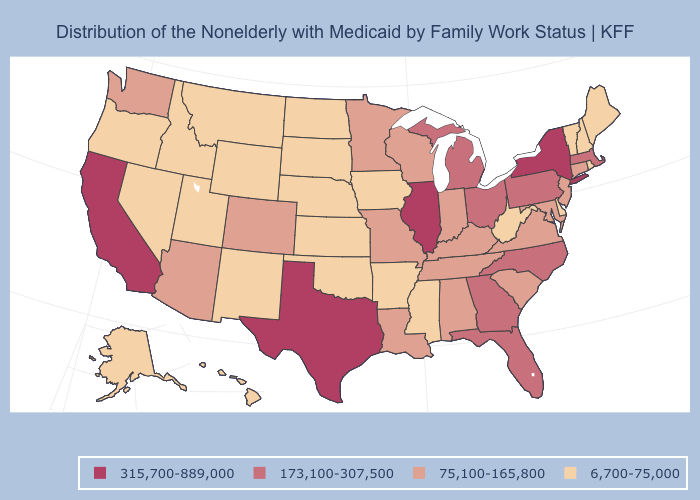Which states have the lowest value in the USA?
Concise answer only. Alaska, Arkansas, Delaware, Hawaii, Idaho, Iowa, Kansas, Maine, Mississippi, Montana, Nebraska, Nevada, New Hampshire, New Mexico, North Dakota, Oklahoma, Oregon, Rhode Island, South Dakota, Utah, Vermont, West Virginia, Wyoming. Which states have the lowest value in the MidWest?
Short answer required. Iowa, Kansas, Nebraska, North Dakota, South Dakota. Which states have the lowest value in the USA?
Keep it brief. Alaska, Arkansas, Delaware, Hawaii, Idaho, Iowa, Kansas, Maine, Mississippi, Montana, Nebraska, Nevada, New Hampshire, New Mexico, North Dakota, Oklahoma, Oregon, Rhode Island, South Dakota, Utah, Vermont, West Virginia, Wyoming. Name the states that have a value in the range 75,100-165,800?
Short answer required. Alabama, Arizona, Colorado, Connecticut, Indiana, Kentucky, Louisiana, Maryland, Minnesota, Missouri, New Jersey, South Carolina, Tennessee, Virginia, Washington, Wisconsin. What is the value of South Dakota?
Short answer required. 6,700-75,000. Which states have the lowest value in the West?
Short answer required. Alaska, Hawaii, Idaho, Montana, Nevada, New Mexico, Oregon, Utah, Wyoming. What is the value of Arizona?
Concise answer only. 75,100-165,800. Which states have the highest value in the USA?
Give a very brief answer. California, Illinois, New York, Texas. Which states have the lowest value in the USA?
Quick response, please. Alaska, Arkansas, Delaware, Hawaii, Idaho, Iowa, Kansas, Maine, Mississippi, Montana, Nebraska, Nevada, New Hampshire, New Mexico, North Dakota, Oklahoma, Oregon, Rhode Island, South Dakota, Utah, Vermont, West Virginia, Wyoming. How many symbols are there in the legend?
Concise answer only. 4. Name the states that have a value in the range 6,700-75,000?
Give a very brief answer. Alaska, Arkansas, Delaware, Hawaii, Idaho, Iowa, Kansas, Maine, Mississippi, Montana, Nebraska, Nevada, New Hampshire, New Mexico, North Dakota, Oklahoma, Oregon, Rhode Island, South Dakota, Utah, Vermont, West Virginia, Wyoming. Does Maine have the lowest value in the USA?
Answer briefly. Yes. What is the value of Alaska?
Keep it brief. 6,700-75,000. Name the states that have a value in the range 315,700-889,000?
Answer briefly. California, Illinois, New York, Texas. Does Indiana have the lowest value in the MidWest?
Short answer required. No. 